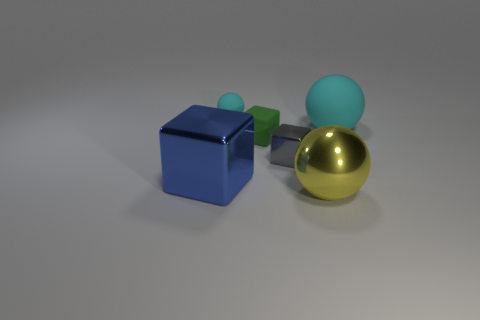There is a big object on the left side of the cyan rubber object on the left side of the tiny shiny object; how many large blue blocks are right of it?
Provide a short and direct response. 0. Is there a thing made of the same material as the gray cube?
Your response must be concise. Yes. What size is the other sphere that is the same color as the large matte sphere?
Keep it short and to the point. Small. Is the number of brown shiny cylinders less than the number of tiny matte blocks?
Your answer should be compact. Yes. There is a metal object that is left of the gray shiny thing; is it the same color as the rubber block?
Give a very brief answer. No. There is a thing that is behind the rubber ball that is right of the small block that is in front of the small green rubber cube; what is its material?
Your answer should be compact. Rubber. Is there a thing of the same color as the rubber cube?
Provide a succinct answer. No. Is the number of tiny rubber things on the right side of the tiny green matte thing less than the number of tiny purple balls?
Keep it short and to the point. No. There is a blue metal object that is in front of the green rubber cube; is its size the same as the gray cube?
Give a very brief answer. No. How many big things are to the left of the big cyan rubber object and on the right side of the large blue cube?
Keep it short and to the point. 1. 